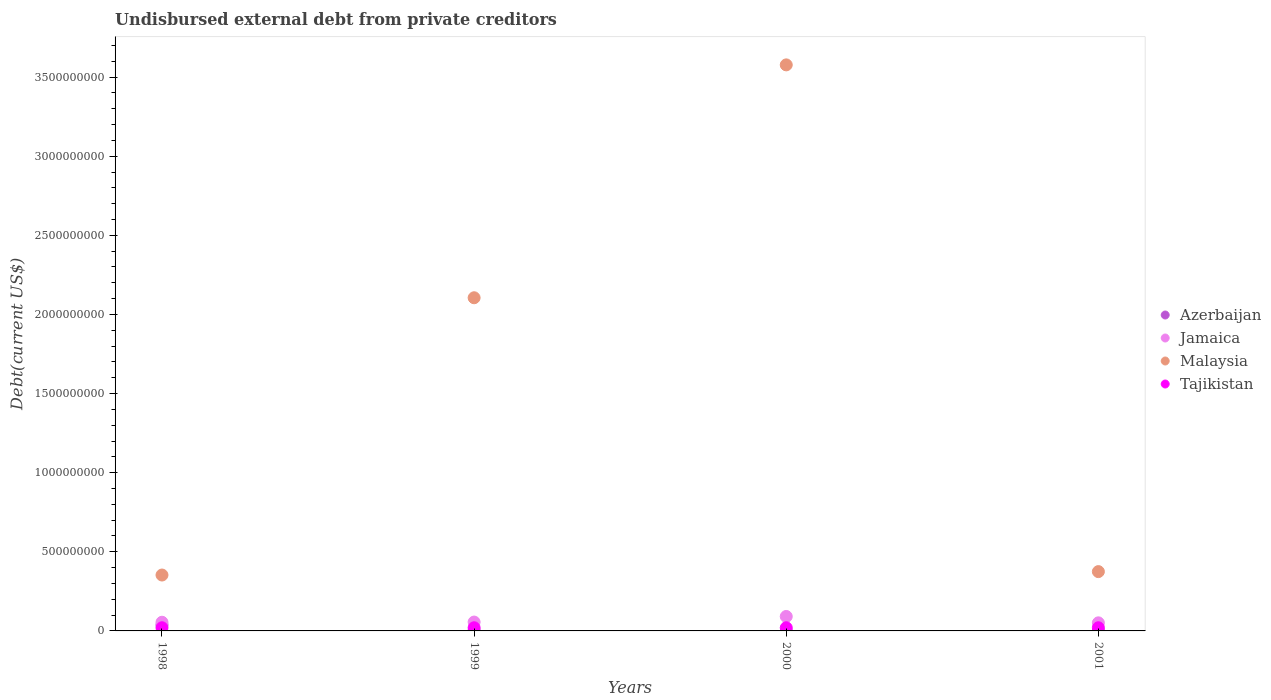What is the total debt in Jamaica in 1999?
Offer a very short reply. 5.60e+07. Across all years, what is the maximum total debt in Malaysia?
Keep it short and to the point. 3.58e+09. Across all years, what is the minimum total debt in Malaysia?
Ensure brevity in your answer.  3.53e+08. What is the total total debt in Tajikistan in the graph?
Provide a succinct answer. 8.00e+07. What is the difference between the total debt in Malaysia in 1998 and the total debt in Azerbaijan in 1999?
Provide a short and direct response. 3.50e+08. What is the average total debt in Jamaica per year?
Keep it short and to the point. 6.33e+07. In the year 1998, what is the difference between the total debt in Tajikistan and total debt in Azerbaijan?
Give a very brief answer. -1.81e+07. In how many years, is the total debt in Malaysia greater than 1900000000 US$?
Keep it short and to the point. 2. Is the total debt in Jamaica in 1998 less than that in 2000?
Ensure brevity in your answer.  Yes. Is the difference between the total debt in Tajikistan in 1999 and 2000 greater than the difference between the total debt in Azerbaijan in 1999 and 2000?
Your answer should be very brief. No. What is the difference between the highest and the second highest total debt in Tajikistan?
Provide a succinct answer. 0. What is the difference between the highest and the lowest total debt in Malaysia?
Your response must be concise. 3.22e+09. Is the sum of the total debt in Tajikistan in 2000 and 2001 greater than the maximum total debt in Jamaica across all years?
Your answer should be very brief. No. Does the total debt in Azerbaijan monotonically increase over the years?
Offer a terse response. No. Is the total debt in Malaysia strictly less than the total debt in Azerbaijan over the years?
Offer a terse response. No. How many dotlines are there?
Your answer should be very brief. 4. What is the difference between two consecutive major ticks on the Y-axis?
Ensure brevity in your answer.  5.00e+08. Are the values on the major ticks of Y-axis written in scientific E-notation?
Keep it short and to the point. No. Does the graph contain any zero values?
Your answer should be compact. No. Does the graph contain grids?
Keep it short and to the point. No. Where does the legend appear in the graph?
Offer a very short reply. Center right. What is the title of the graph?
Give a very brief answer. Undisbursed external debt from private creditors. Does "Micronesia" appear as one of the legend labels in the graph?
Offer a terse response. No. What is the label or title of the X-axis?
Your response must be concise. Years. What is the label or title of the Y-axis?
Offer a very short reply. Debt(current US$). What is the Debt(current US$) of Azerbaijan in 1998?
Provide a succinct answer. 3.81e+07. What is the Debt(current US$) in Jamaica in 1998?
Make the answer very short. 5.49e+07. What is the Debt(current US$) of Malaysia in 1998?
Your answer should be very brief. 3.53e+08. What is the Debt(current US$) of Azerbaijan in 1999?
Provide a succinct answer. 3.53e+06. What is the Debt(current US$) in Jamaica in 1999?
Your response must be concise. 5.60e+07. What is the Debt(current US$) of Malaysia in 1999?
Provide a succinct answer. 2.11e+09. What is the Debt(current US$) in Azerbaijan in 2000?
Offer a terse response. 5.81e+05. What is the Debt(current US$) in Jamaica in 2000?
Your answer should be compact. 9.13e+07. What is the Debt(current US$) of Malaysia in 2000?
Your answer should be compact. 3.58e+09. What is the Debt(current US$) in Tajikistan in 2000?
Provide a succinct answer. 2.00e+07. What is the Debt(current US$) of Azerbaijan in 2001?
Make the answer very short. 4.40e+04. What is the Debt(current US$) of Jamaica in 2001?
Ensure brevity in your answer.  5.11e+07. What is the Debt(current US$) in Malaysia in 2001?
Give a very brief answer. 3.75e+08. What is the Debt(current US$) of Tajikistan in 2001?
Provide a succinct answer. 2.00e+07. Across all years, what is the maximum Debt(current US$) of Azerbaijan?
Your answer should be very brief. 3.81e+07. Across all years, what is the maximum Debt(current US$) in Jamaica?
Your answer should be compact. 9.13e+07. Across all years, what is the maximum Debt(current US$) of Malaysia?
Offer a terse response. 3.58e+09. Across all years, what is the maximum Debt(current US$) in Tajikistan?
Offer a very short reply. 2.00e+07. Across all years, what is the minimum Debt(current US$) of Azerbaijan?
Offer a very short reply. 4.40e+04. Across all years, what is the minimum Debt(current US$) in Jamaica?
Your answer should be compact. 5.11e+07. Across all years, what is the minimum Debt(current US$) in Malaysia?
Make the answer very short. 3.53e+08. What is the total Debt(current US$) of Azerbaijan in the graph?
Offer a terse response. 4.23e+07. What is the total Debt(current US$) of Jamaica in the graph?
Your response must be concise. 2.53e+08. What is the total Debt(current US$) in Malaysia in the graph?
Your response must be concise. 6.41e+09. What is the total Debt(current US$) in Tajikistan in the graph?
Provide a succinct answer. 8.00e+07. What is the difference between the Debt(current US$) of Azerbaijan in 1998 and that in 1999?
Provide a short and direct response. 3.46e+07. What is the difference between the Debt(current US$) in Jamaica in 1998 and that in 1999?
Your response must be concise. -1.14e+06. What is the difference between the Debt(current US$) in Malaysia in 1998 and that in 1999?
Make the answer very short. -1.75e+09. What is the difference between the Debt(current US$) of Azerbaijan in 1998 and that in 2000?
Offer a terse response. 3.76e+07. What is the difference between the Debt(current US$) in Jamaica in 1998 and that in 2000?
Keep it short and to the point. -3.64e+07. What is the difference between the Debt(current US$) in Malaysia in 1998 and that in 2000?
Give a very brief answer. -3.22e+09. What is the difference between the Debt(current US$) in Azerbaijan in 1998 and that in 2001?
Give a very brief answer. 3.81e+07. What is the difference between the Debt(current US$) in Jamaica in 1998 and that in 2001?
Your answer should be very brief. 3.77e+06. What is the difference between the Debt(current US$) in Malaysia in 1998 and that in 2001?
Offer a terse response. -2.16e+07. What is the difference between the Debt(current US$) in Azerbaijan in 1999 and that in 2000?
Provide a short and direct response. 2.95e+06. What is the difference between the Debt(current US$) in Jamaica in 1999 and that in 2000?
Offer a very short reply. -3.53e+07. What is the difference between the Debt(current US$) of Malaysia in 1999 and that in 2000?
Give a very brief answer. -1.47e+09. What is the difference between the Debt(current US$) in Tajikistan in 1999 and that in 2000?
Your response must be concise. 0. What is the difference between the Debt(current US$) in Azerbaijan in 1999 and that in 2001?
Keep it short and to the point. 3.49e+06. What is the difference between the Debt(current US$) in Jamaica in 1999 and that in 2001?
Provide a succinct answer. 4.91e+06. What is the difference between the Debt(current US$) of Malaysia in 1999 and that in 2001?
Provide a succinct answer. 1.73e+09. What is the difference between the Debt(current US$) in Tajikistan in 1999 and that in 2001?
Offer a terse response. 0. What is the difference between the Debt(current US$) in Azerbaijan in 2000 and that in 2001?
Your answer should be compact. 5.37e+05. What is the difference between the Debt(current US$) in Jamaica in 2000 and that in 2001?
Offer a very short reply. 4.02e+07. What is the difference between the Debt(current US$) in Malaysia in 2000 and that in 2001?
Keep it short and to the point. 3.20e+09. What is the difference between the Debt(current US$) of Azerbaijan in 1998 and the Debt(current US$) of Jamaica in 1999?
Keep it short and to the point. -1.79e+07. What is the difference between the Debt(current US$) in Azerbaijan in 1998 and the Debt(current US$) in Malaysia in 1999?
Offer a terse response. -2.07e+09. What is the difference between the Debt(current US$) of Azerbaijan in 1998 and the Debt(current US$) of Tajikistan in 1999?
Provide a succinct answer. 1.81e+07. What is the difference between the Debt(current US$) in Jamaica in 1998 and the Debt(current US$) in Malaysia in 1999?
Offer a terse response. -2.05e+09. What is the difference between the Debt(current US$) of Jamaica in 1998 and the Debt(current US$) of Tajikistan in 1999?
Your answer should be very brief. 3.49e+07. What is the difference between the Debt(current US$) in Malaysia in 1998 and the Debt(current US$) in Tajikistan in 1999?
Your response must be concise. 3.33e+08. What is the difference between the Debt(current US$) in Azerbaijan in 1998 and the Debt(current US$) in Jamaica in 2000?
Offer a very short reply. -5.31e+07. What is the difference between the Debt(current US$) in Azerbaijan in 1998 and the Debt(current US$) in Malaysia in 2000?
Give a very brief answer. -3.54e+09. What is the difference between the Debt(current US$) of Azerbaijan in 1998 and the Debt(current US$) of Tajikistan in 2000?
Provide a short and direct response. 1.81e+07. What is the difference between the Debt(current US$) in Jamaica in 1998 and the Debt(current US$) in Malaysia in 2000?
Offer a terse response. -3.52e+09. What is the difference between the Debt(current US$) of Jamaica in 1998 and the Debt(current US$) of Tajikistan in 2000?
Keep it short and to the point. 3.49e+07. What is the difference between the Debt(current US$) of Malaysia in 1998 and the Debt(current US$) of Tajikistan in 2000?
Ensure brevity in your answer.  3.33e+08. What is the difference between the Debt(current US$) of Azerbaijan in 1998 and the Debt(current US$) of Jamaica in 2001?
Your response must be concise. -1.30e+07. What is the difference between the Debt(current US$) of Azerbaijan in 1998 and the Debt(current US$) of Malaysia in 2001?
Keep it short and to the point. -3.37e+08. What is the difference between the Debt(current US$) of Azerbaijan in 1998 and the Debt(current US$) of Tajikistan in 2001?
Offer a terse response. 1.81e+07. What is the difference between the Debt(current US$) in Jamaica in 1998 and the Debt(current US$) in Malaysia in 2001?
Provide a short and direct response. -3.20e+08. What is the difference between the Debt(current US$) of Jamaica in 1998 and the Debt(current US$) of Tajikistan in 2001?
Give a very brief answer. 3.49e+07. What is the difference between the Debt(current US$) of Malaysia in 1998 and the Debt(current US$) of Tajikistan in 2001?
Make the answer very short. 3.33e+08. What is the difference between the Debt(current US$) in Azerbaijan in 1999 and the Debt(current US$) in Jamaica in 2000?
Your answer should be very brief. -8.78e+07. What is the difference between the Debt(current US$) of Azerbaijan in 1999 and the Debt(current US$) of Malaysia in 2000?
Ensure brevity in your answer.  -3.57e+09. What is the difference between the Debt(current US$) in Azerbaijan in 1999 and the Debt(current US$) in Tajikistan in 2000?
Your response must be concise. -1.65e+07. What is the difference between the Debt(current US$) of Jamaica in 1999 and the Debt(current US$) of Malaysia in 2000?
Offer a terse response. -3.52e+09. What is the difference between the Debt(current US$) of Jamaica in 1999 and the Debt(current US$) of Tajikistan in 2000?
Provide a short and direct response. 3.60e+07. What is the difference between the Debt(current US$) in Malaysia in 1999 and the Debt(current US$) in Tajikistan in 2000?
Your answer should be compact. 2.09e+09. What is the difference between the Debt(current US$) of Azerbaijan in 1999 and the Debt(current US$) of Jamaica in 2001?
Your answer should be very brief. -4.76e+07. What is the difference between the Debt(current US$) in Azerbaijan in 1999 and the Debt(current US$) in Malaysia in 2001?
Provide a short and direct response. -3.71e+08. What is the difference between the Debt(current US$) in Azerbaijan in 1999 and the Debt(current US$) in Tajikistan in 2001?
Give a very brief answer. -1.65e+07. What is the difference between the Debt(current US$) of Jamaica in 1999 and the Debt(current US$) of Malaysia in 2001?
Make the answer very short. -3.19e+08. What is the difference between the Debt(current US$) in Jamaica in 1999 and the Debt(current US$) in Tajikistan in 2001?
Your response must be concise. 3.60e+07. What is the difference between the Debt(current US$) of Malaysia in 1999 and the Debt(current US$) of Tajikistan in 2001?
Your answer should be very brief. 2.09e+09. What is the difference between the Debt(current US$) in Azerbaijan in 2000 and the Debt(current US$) in Jamaica in 2001?
Keep it short and to the point. -5.05e+07. What is the difference between the Debt(current US$) in Azerbaijan in 2000 and the Debt(current US$) in Malaysia in 2001?
Provide a short and direct response. -3.74e+08. What is the difference between the Debt(current US$) in Azerbaijan in 2000 and the Debt(current US$) in Tajikistan in 2001?
Make the answer very short. -1.94e+07. What is the difference between the Debt(current US$) in Jamaica in 2000 and the Debt(current US$) in Malaysia in 2001?
Your answer should be compact. -2.84e+08. What is the difference between the Debt(current US$) in Jamaica in 2000 and the Debt(current US$) in Tajikistan in 2001?
Keep it short and to the point. 7.13e+07. What is the difference between the Debt(current US$) in Malaysia in 2000 and the Debt(current US$) in Tajikistan in 2001?
Provide a short and direct response. 3.56e+09. What is the average Debt(current US$) in Azerbaijan per year?
Keep it short and to the point. 1.06e+07. What is the average Debt(current US$) of Jamaica per year?
Keep it short and to the point. 6.33e+07. What is the average Debt(current US$) in Malaysia per year?
Make the answer very short. 1.60e+09. What is the average Debt(current US$) in Tajikistan per year?
Ensure brevity in your answer.  2.00e+07. In the year 1998, what is the difference between the Debt(current US$) of Azerbaijan and Debt(current US$) of Jamaica?
Ensure brevity in your answer.  -1.67e+07. In the year 1998, what is the difference between the Debt(current US$) of Azerbaijan and Debt(current US$) of Malaysia?
Keep it short and to the point. -3.15e+08. In the year 1998, what is the difference between the Debt(current US$) in Azerbaijan and Debt(current US$) in Tajikistan?
Your response must be concise. 1.81e+07. In the year 1998, what is the difference between the Debt(current US$) of Jamaica and Debt(current US$) of Malaysia?
Provide a succinct answer. -2.98e+08. In the year 1998, what is the difference between the Debt(current US$) of Jamaica and Debt(current US$) of Tajikistan?
Give a very brief answer. 3.49e+07. In the year 1998, what is the difference between the Debt(current US$) of Malaysia and Debt(current US$) of Tajikistan?
Your answer should be very brief. 3.33e+08. In the year 1999, what is the difference between the Debt(current US$) of Azerbaijan and Debt(current US$) of Jamaica?
Your answer should be compact. -5.25e+07. In the year 1999, what is the difference between the Debt(current US$) in Azerbaijan and Debt(current US$) in Malaysia?
Provide a succinct answer. -2.10e+09. In the year 1999, what is the difference between the Debt(current US$) of Azerbaijan and Debt(current US$) of Tajikistan?
Ensure brevity in your answer.  -1.65e+07. In the year 1999, what is the difference between the Debt(current US$) of Jamaica and Debt(current US$) of Malaysia?
Offer a very short reply. -2.05e+09. In the year 1999, what is the difference between the Debt(current US$) of Jamaica and Debt(current US$) of Tajikistan?
Your answer should be compact. 3.60e+07. In the year 1999, what is the difference between the Debt(current US$) in Malaysia and Debt(current US$) in Tajikistan?
Keep it short and to the point. 2.09e+09. In the year 2000, what is the difference between the Debt(current US$) of Azerbaijan and Debt(current US$) of Jamaica?
Your response must be concise. -9.07e+07. In the year 2000, what is the difference between the Debt(current US$) in Azerbaijan and Debt(current US$) in Malaysia?
Keep it short and to the point. -3.58e+09. In the year 2000, what is the difference between the Debt(current US$) in Azerbaijan and Debt(current US$) in Tajikistan?
Your response must be concise. -1.94e+07. In the year 2000, what is the difference between the Debt(current US$) in Jamaica and Debt(current US$) in Malaysia?
Offer a very short reply. -3.49e+09. In the year 2000, what is the difference between the Debt(current US$) of Jamaica and Debt(current US$) of Tajikistan?
Offer a very short reply. 7.13e+07. In the year 2000, what is the difference between the Debt(current US$) of Malaysia and Debt(current US$) of Tajikistan?
Offer a very short reply. 3.56e+09. In the year 2001, what is the difference between the Debt(current US$) in Azerbaijan and Debt(current US$) in Jamaica?
Your answer should be very brief. -5.10e+07. In the year 2001, what is the difference between the Debt(current US$) of Azerbaijan and Debt(current US$) of Malaysia?
Offer a very short reply. -3.75e+08. In the year 2001, what is the difference between the Debt(current US$) of Azerbaijan and Debt(current US$) of Tajikistan?
Provide a succinct answer. -2.00e+07. In the year 2001, what is the difference between the Debt(current US$) of Jamaica and Debt(current US$) of Malaysia?
Offer a very short reply. -3.24e+08. In the year 2001, what is the difference between the Debt(current US$) of Jamaica and Debt(current US$) of Tajikistan?
Make the answer very short. 3.11e+07. In the year 2001, what is the difference between the Debt(current US$) in Malaysia and Debt(current US$) in Tajikistan?
Your answer should be very brief. 3.55e+08. What is the ratio of the Debt(current US$) in Azerbaijan in 1998 to that in 1999?
Keep it short and to the point. 10.8. What is the ratio of the Debt(current US$) of Jamaica in 1998 to that in 1999?
Ensure brevity in your answer.  0.98. What is the ratio of the Debt(current US$) of Malaysia in 1998 to that in 1999?
Make the answer very short. 0.17. What is the ratio of the Debt(current US$) in Tajikistan in 1998 to that in 1999?
Your answer should be compact. 1. What is the ratio of the Debt(current US$) in Azerbaijan in 1998 to that in 2000?
Provide a succinct answer. 65.65. What is the ratio of the Debt(current US$) in Jamaica in 1998 to that in 2000?
Offer a very short reply. 0.6. What is the ratio of the Debt(current US$) of Malaysia in 1998 to that in 2000?
Make the answer very short. 0.1. What is the ratio of the Debt(current US$) in Azerbaijan in 1998 to that in 2001?
Provide a short and direct response. 866.86. What is the ratio of the Debt(current US$) of Jamaica in 1998 to that in 2001?
Provide a succinct answer. 1.07. What is the ratio of the Debt(current US$) of Malaysia in 1998 to that in 2001?
Your answer should be very brief. 0.94. What is the ratio of the Debt(current US$) of Azerbaijan in 1999 to that in 2000?
Offer a terse response. 6.08. What is the ratio of the Debt(current US$) of Jamaica in 1999 to that in 2000?
Give a very brief answer. 0.61. What is the ratio of the Debt(current US$) of Malaysia in 1999 to that in 2000?
Your answer should be very brief. 0.59. What is the ratio of the Debt(current US$) in Tajikistan in 1999 to that in 2000?
Provide a succinct answer. 1. What is the ratio of the Debt(current US$) of Azerbaijan in 1999 to that in 2001?
Offer a very short reply. 80.27. What is the ratio of the Debt(current US$) of Jamaica in 1999 to that in 2001?
Offer a terse response. 1.1. What is the ratio of the Debt(current US$) of Malaysia in 1999 to that in 2001?
Your answer should be compact. 5.62. What is the ratio of the Debt(current US$) of Azerbaijan in 2000 to that in 2001?
Keep it short and to the point. 13.2. What is the ratio of the Debt(current US$) in Jamaica in 2000 to that in 2001?
Your response must be concise. 1.79. What is the ratio of the Debt(current US$) of Malaysia in 2000 to that in 2001?
Keep it short and to the point. 9.54. What is the ratio of the Debt(current US$) of Tajikistan in 2000 to that in 2001?
Make the answer very short. 1. What is the difference between the highest and the second highest Debt(current US$) in Azerbaijan?
Offer a very short reply. 3.46e+07. What is the difference between the highest and the second highest Debt(current US$) in Jamaica?
Ensure brevity in your answer.  3.53e+07. What is the difference between the highest and the second highest Debt(current US$) of Malaysia?
Keep it short and to the point. 1.47e+09. What is the difference between the highest and the lowest Debt(current US$) in Azerbaijan?
Provide a short and direct response. 3.81e+07. What is the difference between the highest and the lowest Debt(current US$) of Jamaica?
Your response must be concise. 4.02e+07. What is the difference between the highest and the lowest Debt(current US$) of Malaysia?
Your answer should be very brief. 3.22e+09. 